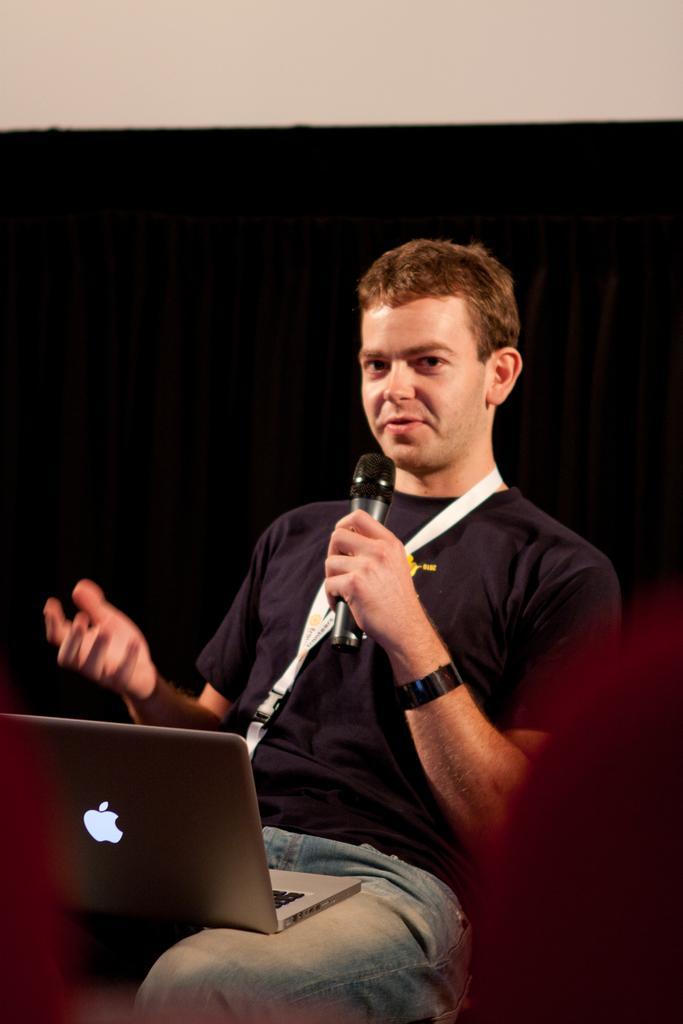In one or two sentences, can you explain what this image depicts? In the middle there is a man ,he wear blue t shirt ,trouser ,watch and tag. he told me ,there is a laptop on his lap. I think he is speaking something. 